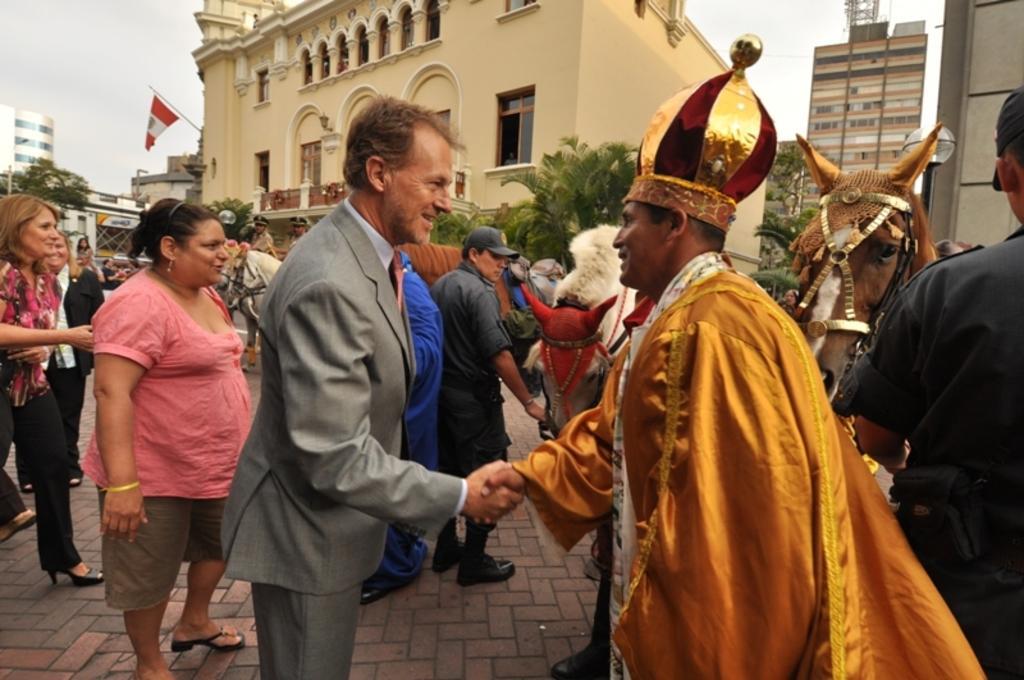Could you give a brief overview of what you see in this image? In the foreground of this image, there are two men shaking hands. In the background, there are many people and horses on the pavement. We can also see few buildings, trees and the sky. 